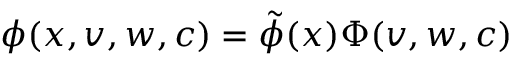Convert formula to latex. <formula><loc_0><loc_0><loc_500><loc_500>\phi ( x , v , w , c ) = \tilde { \phi } ( x ) \Phi ( v , w , c )</formula> 